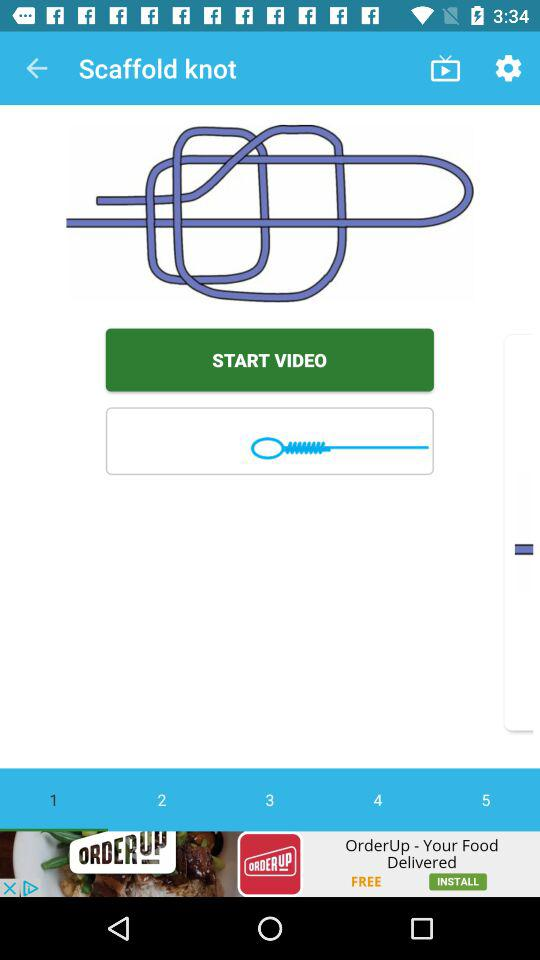What is the name of the application? The name of the application is "Fishing Knots Lite". 